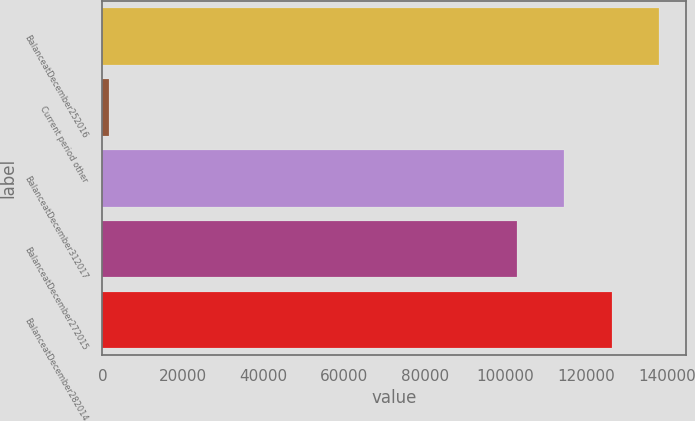<chart> <loc_0><loc_0><loc_500><loc_500><bar_chart><fcel>BalanceatDecember252016<fcel>Current period other<fcel>BalanceatDecember312017<fcel>BalanceatDecember272015<fcel>BalanceatDecember282014<nl><fcel>137985<fcel>1555<fcel>114616<fcel>102931<fcel>126300<nl></chart> 